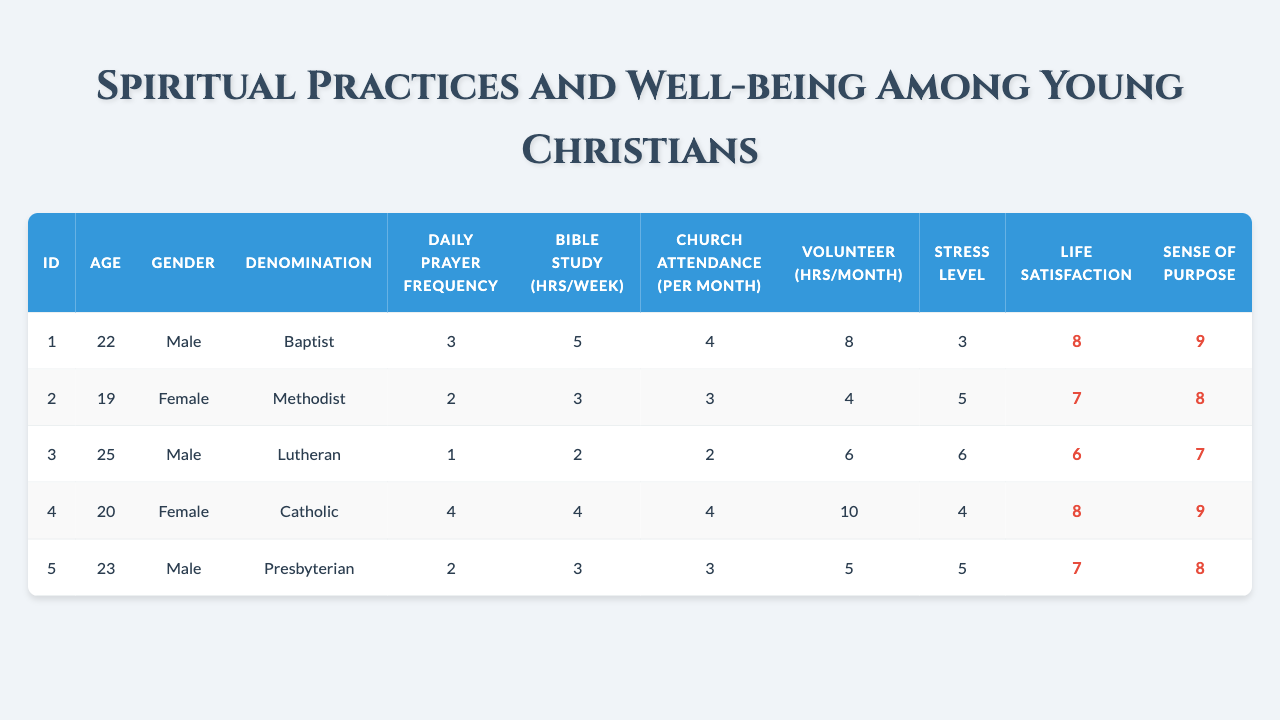What is the daily prayer frequency of the respondent with ID 1? The table shows that for the respondent with ID 1, the daily prayer frequency is listed as 3.
Answer: 3 What denomination does the youngest respondent belong to? The youngest respondent, identified as ID 2, belongs to the Methodist denomination, as shown in the table.
Answer: Methodist How many hours of volunteer work do females report on average? To calculate the average volunteer hours for females, we take the total hours from the two female respondents (10 hours for ID 4 and 4 hours for ID 2) which sums to 14. Dividing by the number of female respondents (2), we get 14/2 = 7.
Answer: 7 Is there a male respondent who volunteers more than 5 hours a month? Looking at the male respondents (ID 1, ID 3, and ID 5), ID 1 reports 8 hours and ID 3 reports 6 hours, both of which are more than 5 hours. Thus, there is more than one male respondent who volunteers more than 5 hours a month.
Answer: Yes What is the average life satisfaction score of the respondents? The life satisfaction scores are 8, 7, 6, 8, and 7 for the respondents respectively. Summing these scores gives 8 + 7 + 6 + 8 + 7 = 36. Dividing this by the number of respondents (5) yields an average of 36/5 = 7.2.
Answer: 7.2 Do all respondents report a stress level of 5 or lower? The stress levels reported by the respondents are 3, 5, 6, 4, and 5. Since one respondent (ID 3) reports a stress level of 6, not all respondents report a stress level of 5 or lower.
Answer: No Who has the highest reported sense of purpose, and what is that value? The sense of purpose scores are 9, 8, 7, 9, and 8. The highest score is 9, which belongs to respondents ID 1 and ID 4.
Answer: ID 1 and ID 4, value 9 What is the total number of hours spent on Bible study per week by all respondents combined? The Bible study hours per week are 5, 3, 2, 4, and 3. Adding these gives 5 + 3 + 2 + 4 + 3 = 17 total hours spent on Bible study by all respondents per week.
Answer: 17 Is a lower stress level associated with higher life satisfaction? To evaluate this, we examine the stress levels and life satisfaction scores: (3, 8), (5, 7), (6, 6), (4, 8), (5, 7). We can see that lower stress levels (3 and 4) correspond with higher life satisfaction scores (8 and 8), suggesting that lower stress may be associated with higher life satisfaction.
Answer: Yes What is the total attendance at church for all respondents in one month? The church attendance per month for all respondents is 4, 3, 2, 4, and 3. Summing these gives 4 + 3 + 2 + 4 + 3 = 16 total church attendances in one month.
Answer: 16 